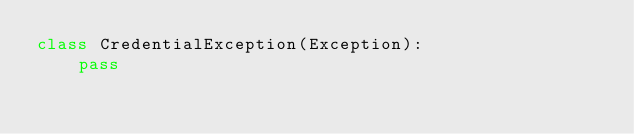Convert code to text. <code><loc_0><loc_0><loc_500><loc_500><_Python_>class CredentialException(Exception):
    pass
</code> 